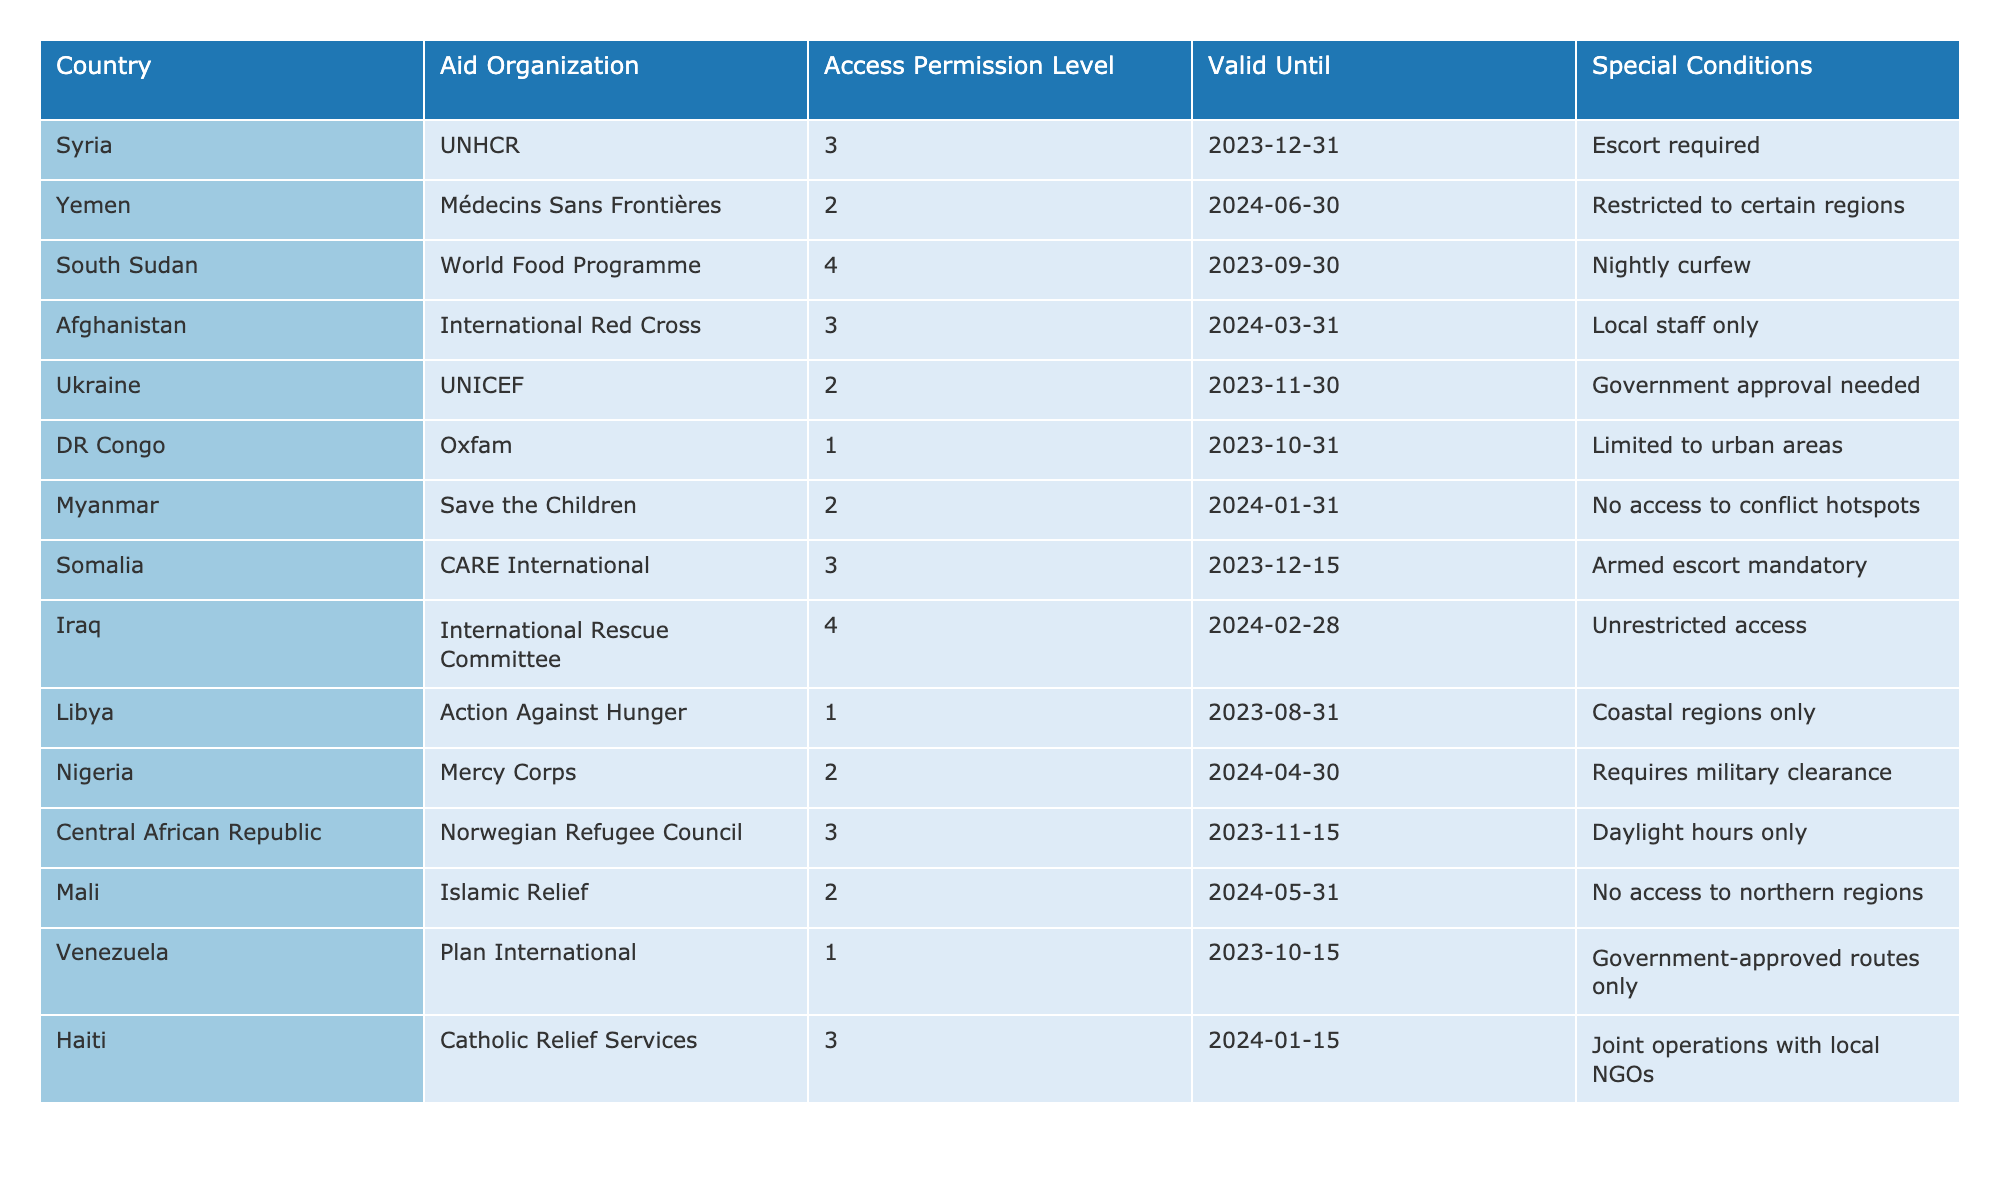What is the access permission level for the World Food Programme in South Sudan? The table shows that the World Food Programme has an access permission level of 4 in South Sudan.
Answer: 4 Which country requires armed escort for aid distribution? According to the table, Somalia requires armed escort for aid distribution, as noted in the special conditions.
Answer: Somalia Are there any countries with unrestricted access permissions? Yes, the table indicates that Iraq has unrestricted access permissions for the International Rescue Committee.
Answer: Yes What is the average access permission level for the organizations listed in the table? To find the average, sum the access levels (3 + 2 + 4 + 3 + 2 + 1 + 2 + 3 + 4 + 1 + 2 + 3 + 2 + 1 + 3) = 2.4, and divide by the total number of organizations (15). The average is 2.4.
Answer: 2.2 Which aid organization has the earliest expiration date for access permission? Review the 'Valid Until' column for dates; Oxfam in DR Congo has the earliest expiration date, which is October 31, 2023.
Answer: Oxfam Are there any countries where aid organizations can only operate during specific hours? Yes, the table shows that in the Central African Republic, aid can only be conducted during daylight hours according to the special conditions.
Answer: Yes What is the difference in access permission levels between the highest and lowest levels in the table? The highest access permission level is 4 (World Food Programme, Iraq) and the lowest is 1 (DR Congo, Libya, Venezuela). The difference is 4 - 1 = 3.
Answer: 3 Which countries require government permission or clearance for aid distribution? According to the table, Yemen, Ukraine, and Nigeria require government clearance or approval for aid distribution in their respective regions.
Answer: Yemen, Ukraine, Nigeria How many organizations have a permission level of 3? Count the entries in the table for access permission level 3: there are 5 organizations (UNHCR, Afghanistan, Somalia, Central African Republic, Haiti).
Answer: 5 Is there any organization operating in a conflict zone without special conditions? By examining the table, it can be seen that all organizations listed have special conditions attached to their operations.
Answer: No 